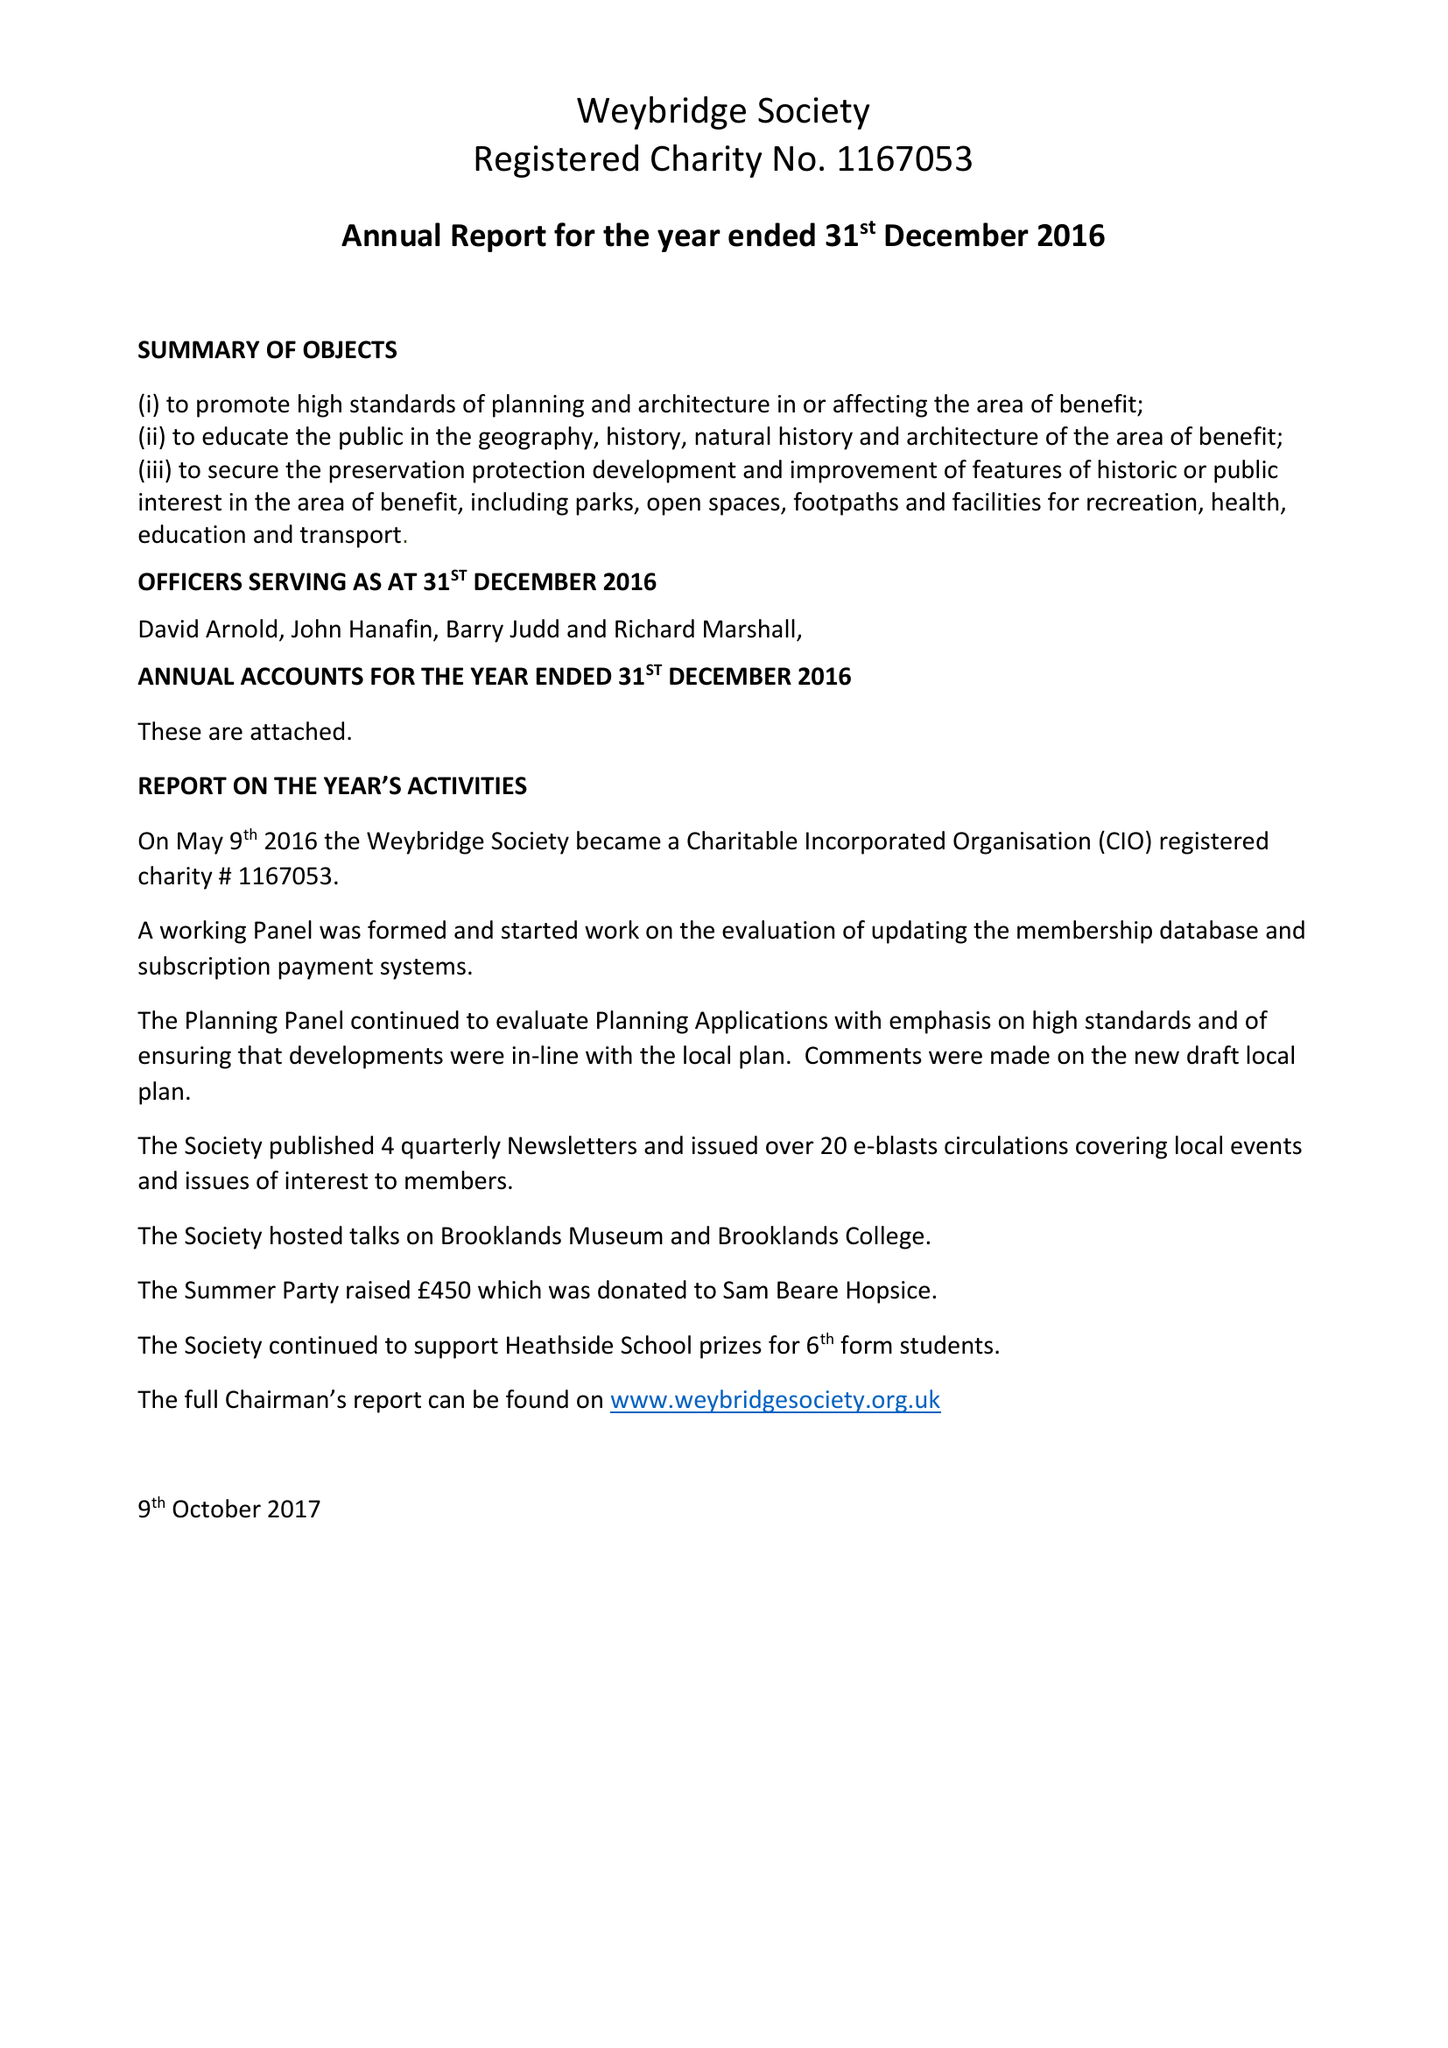What is the value for the charity_name?
Answer the question using a single word or phrase. Weybridge Society 